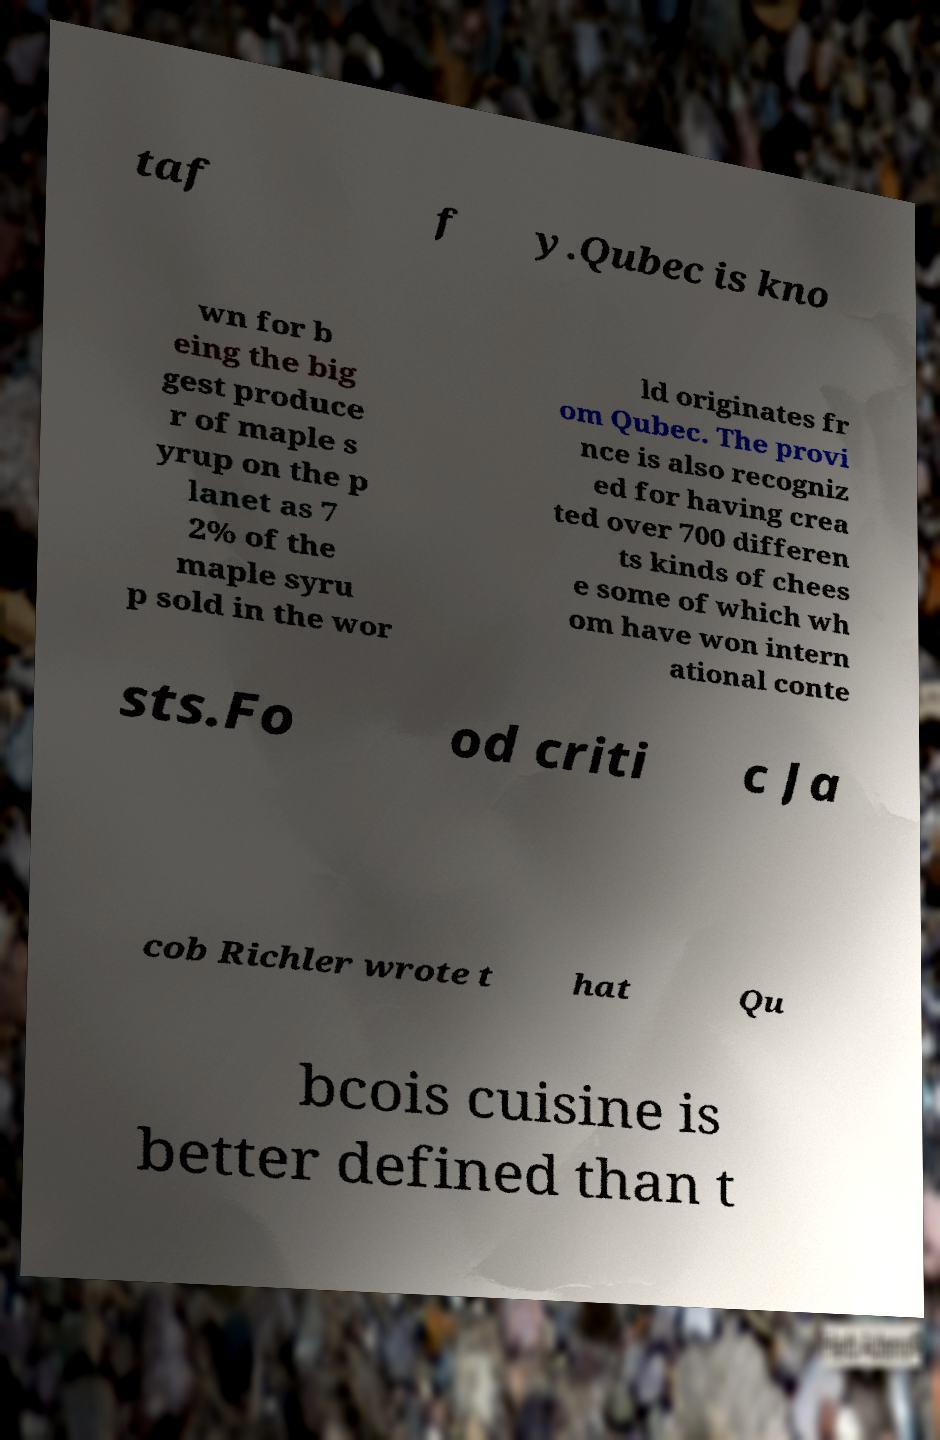Please identify and transcribe the text found in this image. taf f y.Qubec is kno wn for b eing the big gest produce r of maple s yrup on the p lanet as 7 2% of the maple syru p sold in the wor ld originates fr om Qubec. The provi nce is also recogniz ed for having crea ted over 700 differen ts kinds of chees e some of which wh om have won intern ational conte sts.Fo od criti c Ja cob Richler wrote t hat Qu bcois cuisine is better defined than t 